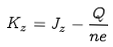<formula> <loc_0><loc_0><loc_500><loc_500>K _ { z } = J _ { z } - \frac { Q } { n e }</formula> 